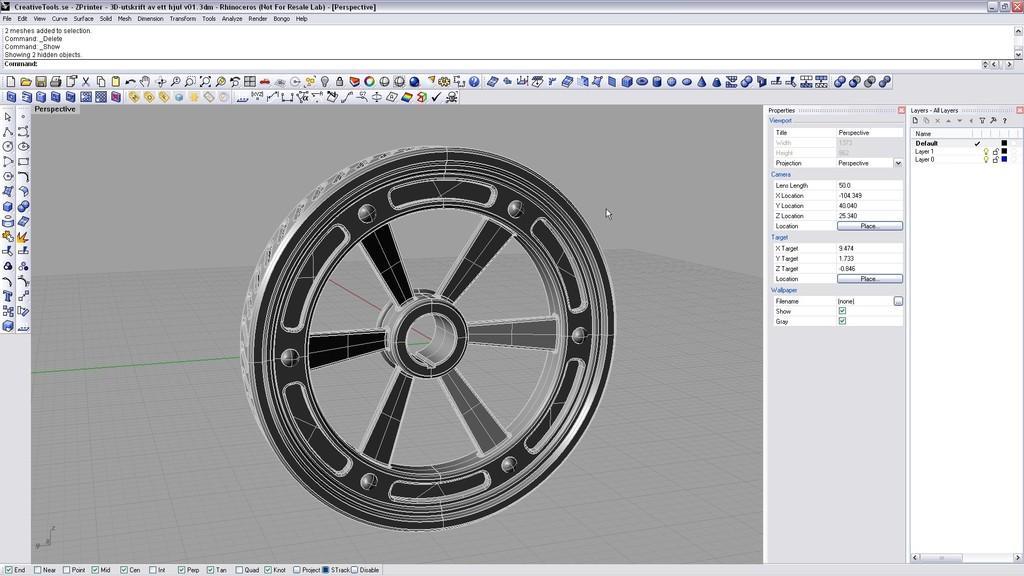Please provide a concise description of this image. This is the screenshot of a computer with a wheel in the middle and toolbar above it. 